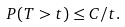Convert formula to latex. <formula><loc_0><loc_0><loc_500><loc_500>P ( T > t ) \leq C / t .</formula> 